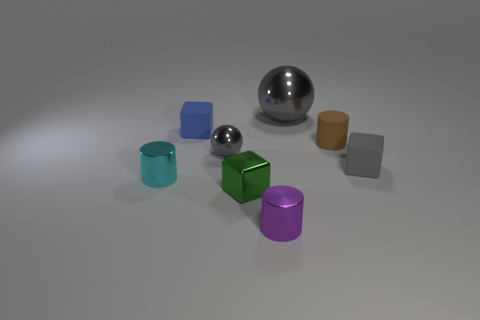Subtract all small rubber cylinders. How many cylinders are left? 2 Add 1 big blue metal things. How many objects exist? 9 Subtract 3 cylinders. How many cylinders are left? 0 Add 1 small matte cylinders. How many small matte cylinders exist? 2 Subtract all purple cylinders. How many cylinders are left? 2 Subtract 1 gray spheres. How many objects are left? 7 Subtract all cylinders. How many objects are left? 5 Subtract all gray blocks. Subtract all cyan balls. How many blocks are left? 2 Subtract all gray spheres. How many gray blocks are left? 1 Subtract all purple objects. Subtract all large gray spheres. How many objects are left? 6 